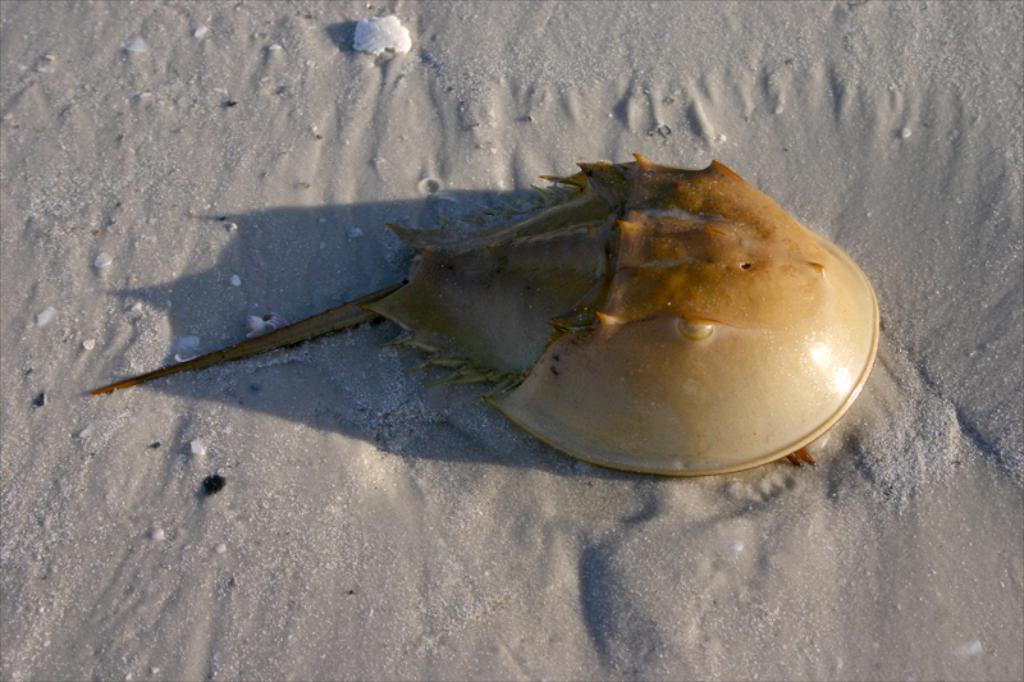Could you give a brief overview of what you see in this image? This is a zoomed in picture. In the center there is an object seems to be a skate fish and we can see the mud on the ground. 